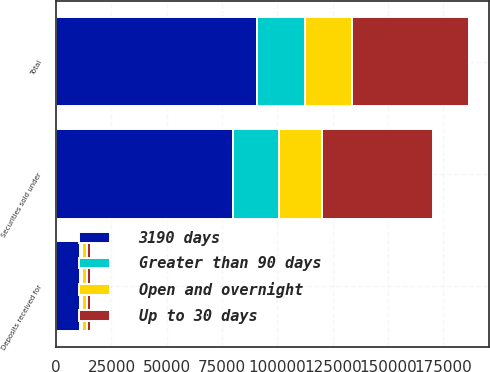Convert chart. <chart><loc_0><loc_0><loc_500><loc_500><stacked_bar_chart><ecel><fcel>Securities sold under<fcel>Deposits received for<fcel>Total<nl><fcel>3190 days<fcel>79740<fcel>10813<fcel>90553<nl><fcel>Up to 30 days<fcel>50399<fcel>2169<fcel>52568<nl><fcel>Open and overnight<fcel>19396<fcel>2044<fcel>21440<nl><fcel>Greater than 90 days<fcel>20961<fcel>932<fcel>21893<nl></chart> 